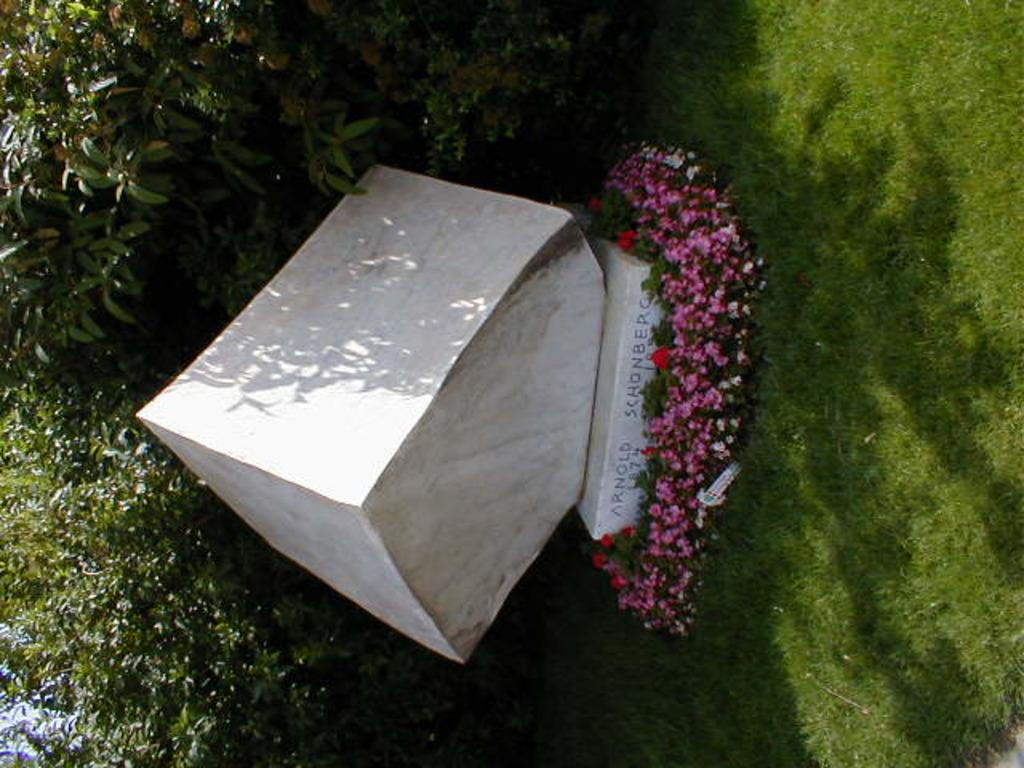What is the main subject of the image? There is a memorial in the image. What can be seen in front of the memorial? There are flowers in front of the memorial. What colors are the flowers? The flowers are red and pink in color. What is visible in the background of the image? There are many trees in the background of the image. What type of pot is holding the button in the image? There is no pot or button present in the image. How many men are visible in the image? There is no mention of men in the provided facts, so we cannot determine the number of men in the image. 